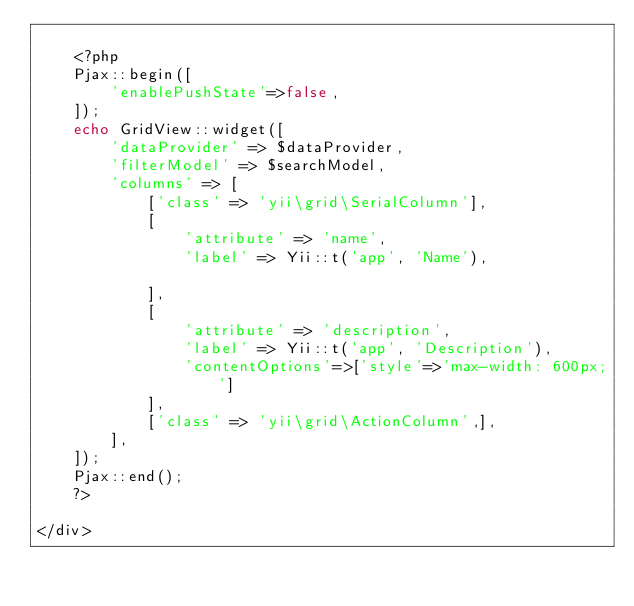Convert code to text. <code><loc_0><loc_0><loc_500><loc_500><_PHP_>
    <?php
    Pjax::begin([
        'enablePushState'=>false,
    ]);
    echo GridView::widget([
        'dataProvider' => $dataProvider,
        'filterModel' => $searchModel,
        'columns' => [
            ['class' => 'yii\grid\SerialColumn'],
            [
                'attribute' => 'name',
                'label' => Yii::t('app', 'Name'),
                 
            ],
            [
                'attribute' => 'description',
                'label' => Yii::t('app', 'Description'),
                'contentOptions'=>['style'=>'max-width: 600px;']
            ],
            ['class' => 'yii\grid\ActionColumn',],
        ],
    ]);
    Pjax::end();
    ?>

</div>
</code> 